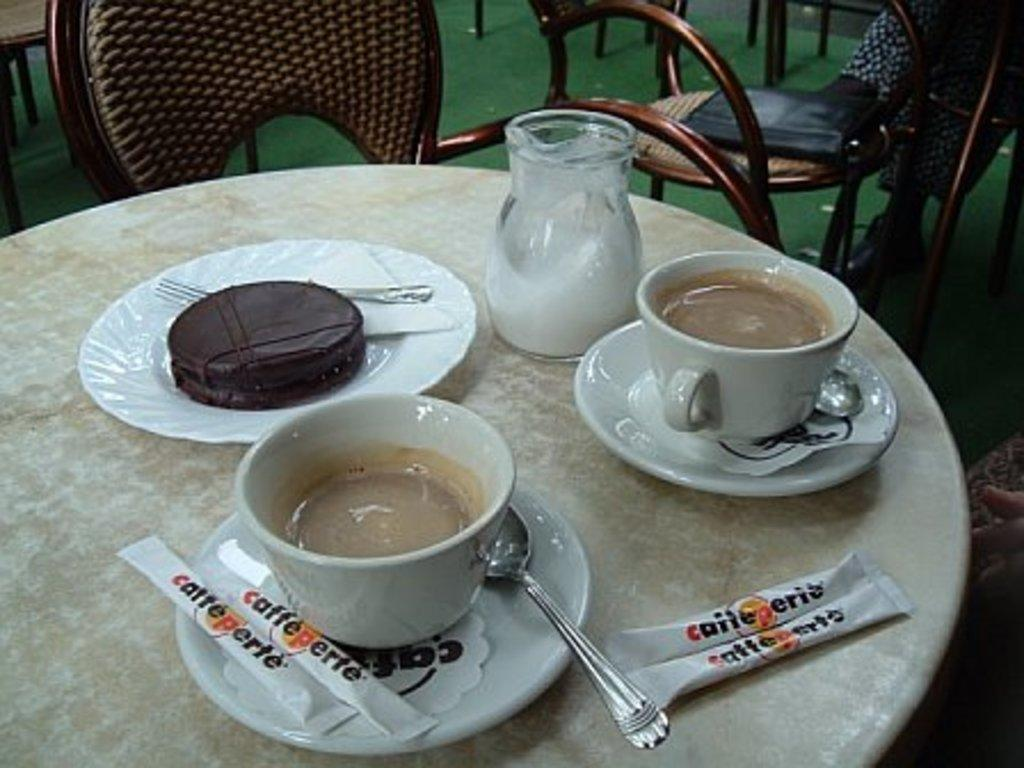What is in the cups that are visible in the image? There is coffee in cups in the image. What utensils can be seen in the image? Spoons and forks are present in the image. What type of dishware is visible in the image? There are saucers, plates, and cups visible in the image. What container is present in the image? There is a jar in the image. What furniture can be seen in the background of the image? There are chairs in the background of the image. Can you tell me how many crows are resting on the chairs in the image? There are no crows present in the image; it features coffee in cups, utensils, dishware, a jar, and chairs. 